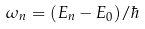Convert formula to latex. <formula><loc_0><loc_0><loc_500><loc_500>\omega _ { n } = ( E _ { n } - E _ { 0 } ) / \hbar</formula> 